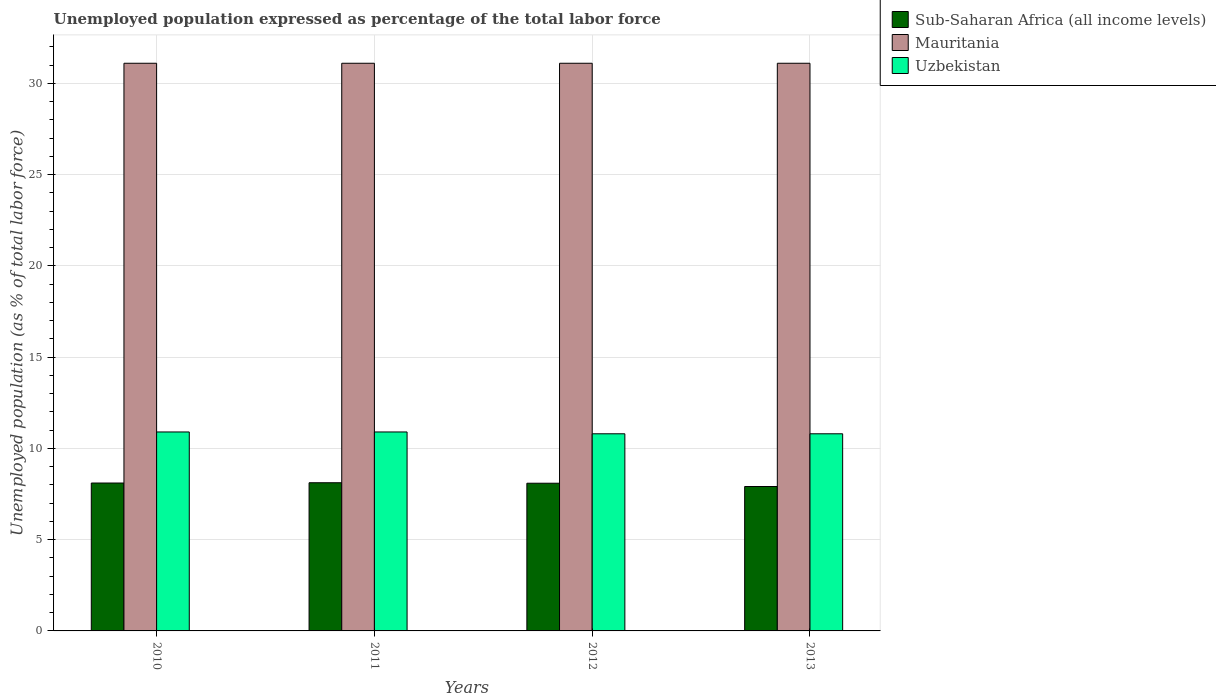How many different coloured bars are there?
Provide a short and direct response. 3. Are the number of bars per tick equal to the number of legend labels?
Make the answer very short. Yes. Are the number of bars on each tick of the X-axis equal?
Offer a very short reply. Yes. How many bars are there on the 4th tick from the left?
Your response must be concise. 3. In how many cases, is the number of bars for a given year not equal to the number of legend labels?
Provide a succinct answer. 0. What is the unemployment in in Mauritania in 2011?
Ensure brevity in your answer.  31.1. Across all years, what is the maximum unemployment in in Uzbekistan?
Provide a succinct answer. 10.9. Across all years, what is the minimum unemployment in in Mauritania?
Ensure brevity in your answer.  31.1. In which year was the unemployment in in Uzbekistan maximum?
Your answer should be compact. 2010. In which year was the unemployment in in Uzbekistan minimum?
Give a very brief answer. 2012. What is the total unemployment in in Uzbekistan in the graph?
Offer a very short reply. 43.4. What is the difference between the unemployment in in Mauritania in 2010 and the unemployment in in Uzbekistan in 2013?
Offer a very short reply. 20.3. What is the average unemployment in in Sub-Saharan Africa (all income levels) per year?
Offer a very short reply. 8.06. In the year 2010, what is the difference between the unemployment in in Uzbekistan and unemployment in in Sub-Saharan Africa (all income levels)?
Offer a terse response. 2.8. What is the ratio of the unemployment in in Uzbekistan in 2010 to that in 2013?
Give a very brief answer. 1.01. What is the difference between the highest and the second highest unemployment in in Uzbekistan?
Your answer should be compact. 0. What is the difference between the highest and the lowest unemployment in in Uzbekistan?
Provide a short and direct response. 0.1. Is the sum of the unemployment in in Uzbekistan in 2010 and 2012 greater than the maximum unemployment in in Mauritania across all years?
Ensure brevity in your answer.  No. What does the 2nd bar from the left in 2013 represents?
Make the answer very short. Mauritania. What does the 3rd bar from the right in 2010 represents?
Your response must be concise. Sub-Saharan Africa (all income levels). Is it the case that in every year, the sum of the unemployment in in Mauritania and unemployment in in Uzbekistan is greater than the unemployment in in Sub-Saharan Africa (all income levels)?
Keep it short and to the point. Yes. Are all the bars in the graph horizontal?
Offer a terse response. No. What is the difference between two consecutive major ticks on the Y-axis?
Provide a short and direct response. 5. Does the graph contain any zero values?
Your response must be concise. No. Does the graph contain grids?
Offer a very short reply. Yes. What is the title of the graph?
Offer a terse response. Unemployed population expressed as percentage of the total labor force. Does "Croatia" appear as one of the legend labels in the graph?
Make the answer very short. No. What is the label or title of the X-axis?
Keep it short and to the point. Years. What is the label or title of the Y-axis?
Give a very brief answer. Unemployed population (as % of total labor force). What is the Unemployed population (as % of total labor force) of Sub-Saharan Africa (all income levels) in 2010?
Ensure brevity in your answer.  8.1. What is the Unemployed population (as % of total labor force) of Mauritania in 2010?
Your response must be concise. 31.1. What is the Unemployed population (as % of total labor force) in Uzbekistan in 2010?
Offer a very short reply. 10.9. What is the Unemployed population (as % of total labor force) in Sub-Saharan Africa (all income levels) in 2011?
Offer a terse response. 8.12. What is the Unemployed population (as % of total labor force) in Mauritania in 2011?
Ensure brevity in your answer.  31.1. What is the Unemployed population (as % of total labor force) in Uzbekistan in 2011?
Give a very brief answer. 10.9. What is the Unemployed population (as % of total labor force) of Sub-Saharan Africa (all income levels) in 2012?
Offer a very short reply. 8.09. What is the Unemployed population (as % of total labor force) in Mauritania in 2012?
Your response must be concise. 31.1. What is the Unemployed population (as % of total labor force) of Uzbekistan in 2012?
Your answer should be very brief. 10.8. What is the Unemployed population (as % of total labor force) of Sub-Saharan Africa (all income levels) in 2013?
Offer a very short reply. 7.91. What is the Unemployed population (as % of total labor force) in Mauritania in 2013?
Give a very brief answer. 31.1. What is the Unemployed population (as % of total labor force) in Uzbekistan in 2013?
Offer a terse response. 10.8. Across all years, what is the maximum Unemployed population (as % of total labor force) of Sub-Saharan Africa (all income levels)?
Provide a succinct answer. 8.12. Across all years, what is the maximum Unemployed population (as % of total labor force) in Mauritania?
Give a very brief answer. 31.1. Across all years, what is the maximum Unemployed population (as % of total labor force) of Uzbekistan?
Give a very brief answer. 10.9. Across all years, what is the minimum Unemployed population (as % of total labor force) in Sub-Saharan Africa (all income levels)?
Your answer should be very brief. 7.91. Across all years, what is the minimum Unemployed population (as % of total labor force) of Mauritania?
Make the answer very short. 31.1. Across all years, what is the minimum Unemployed population (as % of total labor force) of Uzbekistan?
Make the answer very short. 10.8. What is the total Unemployed population (as % of total labor force) of Sub-Saharan Africa (all income levels) in the graph?
Offer a terse response. 32.22. What is the total Unemployed population (as % of total labor force) in Mauritania in the graph?
Your answer should be very brief. 124.4. What is the total Unemployed population (as % of total labor force) of Uzbekistan in the graph?
Provide a short and direct response. 43.4. What is the difference between the Unemployed population (as % of total labor force) in Sub-Saharan Africa (all income levels) in 2010 and that in 2011?
Provide a short and direct response. -0.02. What is the difference between the Unemployed population (as % of total labor force) in Sub-Saharan Africa (all income levels) in 2010 and that in 2012?
Keep it short and to the point. 0.01. What is the difference between the Unemployed population (as % of total labor force) in Mauritania in 2010 and that in 2012?
Offer a very short reply. 0. What is the difference between the Unemployed population (as % of total labor force) in Sub-Saharan Africa (all income levels) in 2010 and that in 2013?
Ensure brevity in your answer.  0.19. What is the difference between the Unemployed population (as % of total labor force) in Uzbekistan in 2010 and that in 2013?
Provide a succinct answer. 0.1. What is the difference between the Unemployed population (as % of total labor force) of Sub-Saharan Africa (all income levels) in 2011 and that in 2012?
Provide a succinct answer. 0.03. What is the difference between the Unemployed population (as % of total labor force) in Mauritania in 2011 and that in 2012?
Make the answer very short. 0. What is the difference between the Unemployed population (as % of total labor force) of Sub-Saharan Africa (all income levels) in 2011 and that in 2013?
Your answer should be compact. 0.21. What is the difference between the Unemployed population (as % of total labor force) of Mauritania in 2011 and that in 2013?
Keep it short and to the point. 0. What is the difference between the Unemployed population (as % of total labor force) in Sub-Saharan Africa (all income levels) in 2012 and that in 2013?
Make the answer very short. 0.18. What is the difference between the Unemployed population (as % of total labor force) in Sub-Saharan Africa (all income levels) in 2010 and the Unemployed population (as % of total labor force) in Mauritania in 2011?
Make the answer very short. -23. What is the difference between the Unemployed population (as % of total labor force) of Sub-Saharan Africa (all income levels) in 2010 and the Unemployed population (as % of total labor force) of Uzbekistan in 2011?
Provide a succinct answer. -2.8. What is the difference between the Unemployed population (as % of total labor force) in Mauritania in 2010 and the Unemployed population (as % of total labor force) in Uzbekistan in 2011?
Make the answer very short. 20.2. What is the difference between the Unemployed population (as % of total labor force) of Sub-Saharan Africa (all income levels) in 2010 and the Unemployed population (as % of total labor force) of Mauritania in 2012?
Provide a succinct answer. -23. What is the difference between the Unemployed population (as % of total labor force) in Sub-Saharan Africa (all income levels) in 2010 and the Unemployed population (as % of total labor force) in Uzbekistan in 2012?
Offer a very short reply. -2.7. What is the difference between the Unemployed population (as % of total labor force) of Mauritania in 2010 and the Unemployed population (as % of total labor force) of Uzbekistan in 2012?
Your answer should be very brief. 20.3. What is the difference between the Unemployed population (as % of total labor force) of Sub-Saharan Africa (all income levels) in 2010 and the Unemployed population (as % of total labor force) of Mauritania in 2013?
Offer a very short reply. -23. What is the difference between the Unemployed population (as % of total labor force) of Sub-Saharan Africa (all income levels) in 2010 and the Unemployed population (as % of total labor force) of Uzbekistan in 2013?
Your answer should be compact. -2.7. What is the difference between the Unemployed population (as % of total labor force) of Mauritania in 2010 and the Unemployed population (as % of total labor force) of Uzbekistan in 2013?
Your answer should be very brief. 20.3. What is the difference between the Unemployed population (as % of total labor force) of Sub-Saharan Africa (all income levels) in 2011 and the Unemployed population (as % of total labor force) of Mauritania in 2012?
Your answer should be very brief. -22.98. What is the difference between the Unemployed population (as % of total labor force) of Sub-Saharan Africa (all income levels) in 2011 and the Unemployed population (as % of total labor force) of Uzbekistan in 2012?
Ensure brevity in your answer.  -2.68. What is the difference between the Unemployed population (as % of total labor force) of Mauritania in 2011 and the Unemployed population (as % of total labor force) of Uzbekistan in 2012?
Provide a succinct answer. 20.3. What is the difference between the Unemployed population (as % of total labor force) of Sub-Saharan Africa (all income levels) in 2011 and the Unemployed population (as % of total labor force) of Mauritania in 2013?
Your response must be concise. -22.98. What is the difference between the Unemployed population (as % of total labor force) in Sub-Saharan Africa (all income levels) in 2011 and the Unemployed population (as % of total labor force) in Uzbekistan in 2013?
Ensure brevity in your answer.  -2.68. What is the difference between the Unemployed population (as % of total labor force) in Mauritania in 2011 and the Unemployed population (as % of total labor force) in Uzbekistan in 2013?
Keep it short and to the point. 20.3. What is the difference between the Unemployed population (as % of total labor force) of Sub-Saharan Africa (all income levels) in 2012 and the Unemployed population (as % of total labor force) of Mauritania in 2013?
Your answer should be very brief. -23.01. What is the difference between the Unemployed population (as % of total labor force) in Sub-Saharan Africa (all income levels) in 2012 and the Unemployed population (as % of total labor force) in Uzbekistan in 2013?
Keep it short and to the point. -2.71. What is the difference between the Unemployed population (as % of total labor force) of Mauritania in 2012 and the Unemployed population (as % of total labor force) of Uzbekistan in 2013?
Your response must be concise. 20.3. What is the average Unemployed population (as % of total labor force) in Sub-Saharan Africa (all income levels) per year?
Your answer should be compact. 8.06. What is the average Unemployed population (as % of total labor force) of Mauritania per year?
Your answer should be very brief. 31.1. What is the average Unemployed population (as % of total labor force) of Uzbekistan per year?
Make the answer very short. 10.85. In the year 2010, what is the difference between the Unemployed population (as % of total labor force) in Sub-Saharan Africa (all income levels) and Unemployed population (as % of total labor force) in Mauritania?
Your answer should be very brief. -23. In the year 2010, what is the difference between the Unemployed population (as % of total labor force) in Sub-Saharan Africa (all income levels) and Unemployed population (as % of total labor force) in Uzbekistan?
Provide a short and direct response. -2.8. In the year 2010, what is the difference between the Unemployed population (as % of total labor force) of Mauritania and Unemployed population (as % of total labor force) of Uzbekistan?
Keep it short and to the point. 20.2. In the year 2011, what is the difference between the Unemployed population (as % of total labor force) in Sub-Saharan Africa (all income levels) and Unemployed population (as % of total labor force) in Mauritania?
Make the answer very short. -22.98. In the year 2011, what is the difference between the Unemployed population (as % of total labor force) in Sub-Saharan Africa (all income levels) and Unemployed population (as % of total labor force) in Uzbekistan?
Make the answer very short. -2.78. In the year 2011, what is the difference between the Unemployed population (as % of total labor force) of Mauritania and Unemployed population (as % of total labor force) of Uzbekistan?
Keep it short and to the point. 20.2. In the year 2012, what is the difference between the Unemployed population (as % of total labor force) in Sub-Saharan Africa (all income levels) and Unemployed population (as % of total labor force) in Mauritania?
Provide a short and direct response. -23.01. In the year 2012, what is the difference between the Unemployed population (as % of total labor force) in Sub-Saharan Africa (all income levels) and Unemployed population (as % of total labor force) in Uzbekistan?
Your response must be concise. -2.71. In the year 2012, what is the difference between the Unemployed population (as % of total labor force) of Mauritania and Unemployed population (as % of total labor force) of Uzbekistan?
Your answer should be compact. 20.3. In the year 2013, what is the difference between the Unemployed population (as % of total labor force) of Sub-Saharan Africa (all income levels) and Unemployed population (as % of total labor force) of Mauritania?
Ensure brevity in your answer.  -23.19. In the year 2013, what is the difference between the Unemployed population (as % of total labor force) in Sub-Saharan Africa (all income levels) and Unemployed population (as % of total labor force) in Uzbekistan?
Ensure brevity in your answer.  -2.89. In the year 2013, what is the difference between the Unemployed population (as % of total labor force) of Mauritania and Unemployed population (as % of total labor force) of Uzbekistan?
Provide a succinct answer. 20.3. What is the ratio of the Unemployed population (as % of total labor force) of Sub-Saharan Africa (all income levels) in 2010 to that in 2011?
Ensure brevity in your answer.  1. What is the ratio of the Unemployed population (as % of total labor force) in Mauritania in 2010 to that in 2011?
Provide a short and direct response. 1. What is the ratio of the Unemployed population (as % of total labor force) in Sub-Saharan Africa (all income levels) in 2010 to that in 2012?
Your answer should be compact. 1. What is the ratio of the Unemployed population (as % of total labor force) of Mauritania in 2010 to that in 2012?
Offer a very short reply. 1. What is the ratio of the Unemployed population (as % of total labor force) in Uzbekistan in 2010 to that in 2012?
Make the answer very short. 1.01. What is the ratio of the Unemployed population (as % of total labor force) in Sub-Saharan Africa (all income levels) in 2010 to that in 2013?
Offer a terse response. 1.02. What is the ratio of the Unemployed population (as % of total labor force) in Mauritania in 2010 to that in 2013?
Provide a short and direct response. 1. What is the ratio of the Unemployed population (as % of total labor force) of Uzbekistan in 2010 to that in 2013?
Give a very brief answer. 1.01. What is the ratio of the Unemployed population (as % of total labor force) of Mauritania in 2011 to that in 2012?
Your response must be concise. 1. What is the ratio of the Unemployed population (as % of total labor force) in Uzbekistan in 2011 to that in 2012?
Offer a very short reply. 1.01. What is the ratio of the Unemployed population (as % of total labor force) in Sub-Saharan Africa (all income levels) in 2011 to that in 2013?
Make the answer very short. 1.03. What is the ratio of the Unemployed population (as % of total labor force) of Uzbekistan in 2011 to that in 2013?
Offer a very short reply. 1.01. What is the ratio of the Unemployed population (as % of total labor force) of Sub-Saharan Africa (all income levels) in 2012 to that in 2013?
Give a very brief answer. 1.02. What is the ratio of the Unemployed population (as % of total labor force) in Mauritania in 2012 to that in 2013?
Your answer should be compact. 1. What is the ratio of the Unemployed population (as % of total labor force) in Uzbekistan in 2012 to that in 2013?
Ensure brevity in your answer.  1. What is the difference between the highest and the second highest Unemployed population (as % of total labor force) of Sub-Saharan Africa (all income levels)?
Keep it short and to the point. 0.02. What is the difference between the highest and the second highest Unemployed population (as % of total labor force) of Mauritania?
Make the answer very short. 0. What is the difference between the highest and the lowest Unemployed population (as % of total labor force) of Sub-Saharan Africa (all income levels)?
Ensure brevity in your answer.  0.21. 